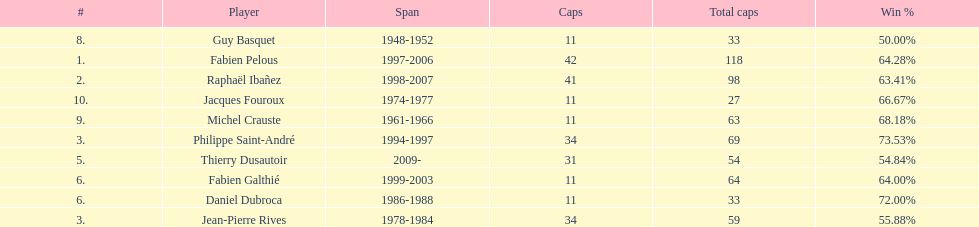Which player has the highest win percentage? Philippe Saint-André. 